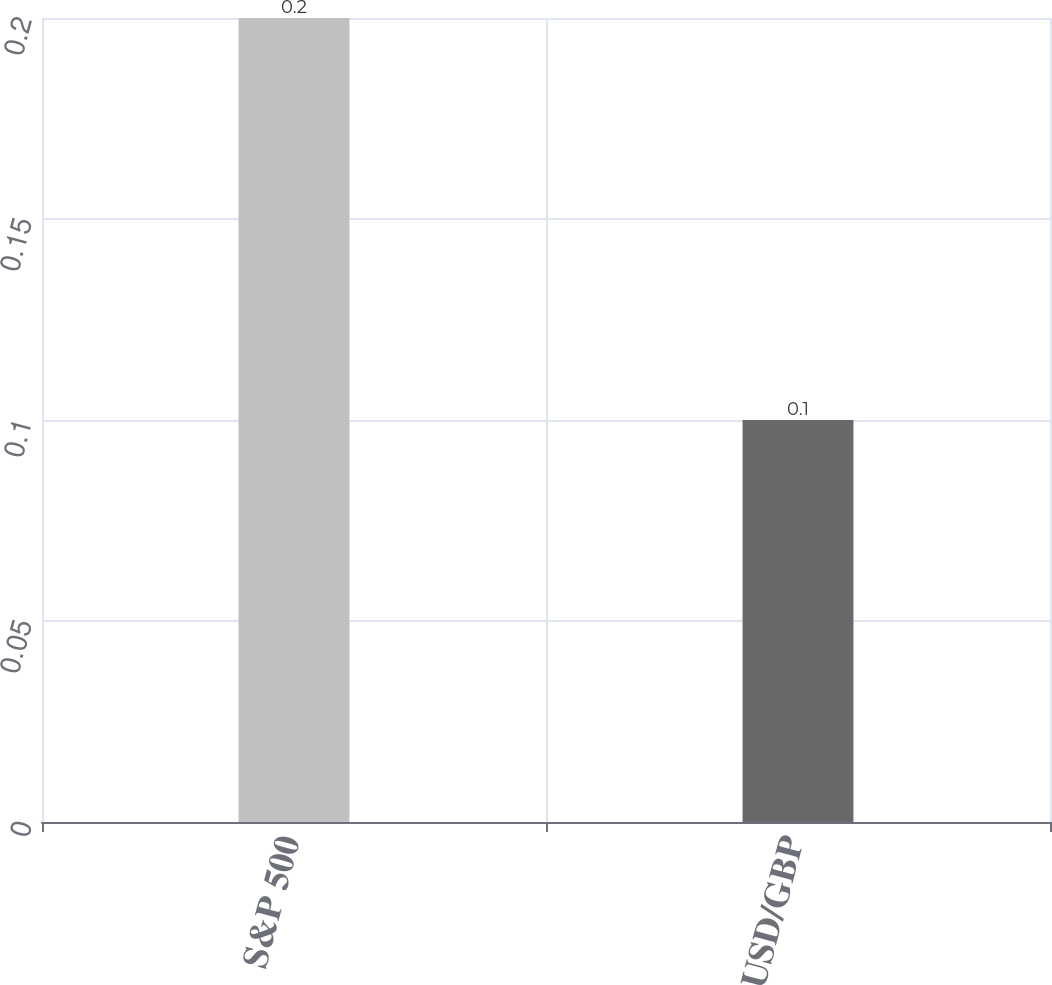Convert chart to OTSL. <chart><loc_0><loc_0><loc_500><loc_500><bar_chart><fcel>S&P 500<fcel>USD/GBP<nl><fcel>0.2<fcel>0.1<nl></chart> 